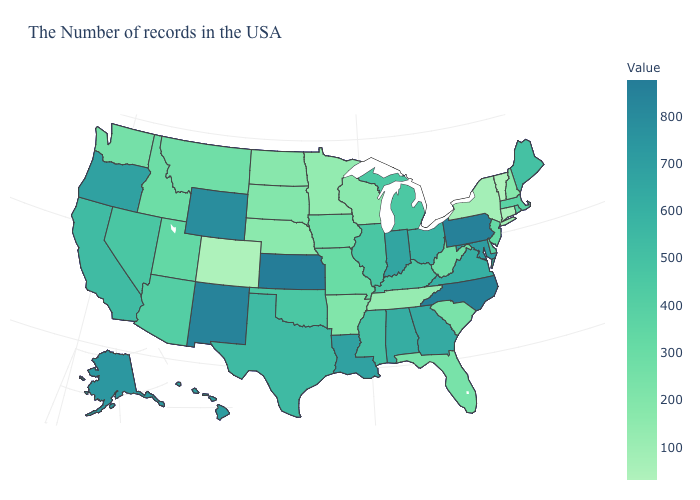Is the legend a continuous bar?
Be succinct. Yes. Which states hav the highest value in the MidWest?
Concise answer only. Kansas. Does North Dakota have the lowest value in the USA?
Keep it brief. No. Is the legend a continuous bar?
Answer briefly. Yes. Among the states that border Missouri , does Tennessee have the lowest value?
Quick response, please. Yes. Does Arkansas have the highest value in the USA?
Be succinct. No. 